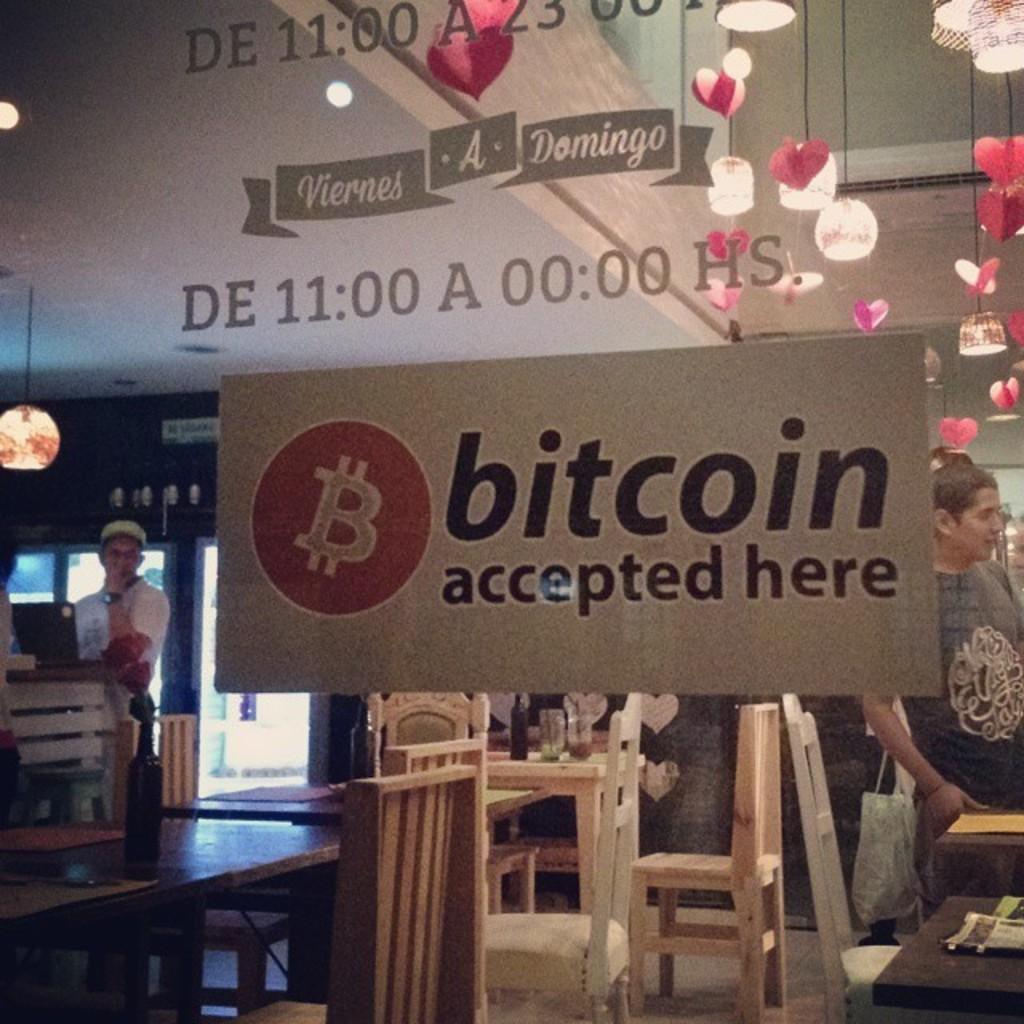In one or two sentences, can you explain what this image depicts? In this picture we can see two persons standing and we have tables and chairs and on table we can see bottles, papers and in background we can see lights, banners and some decorative items. 